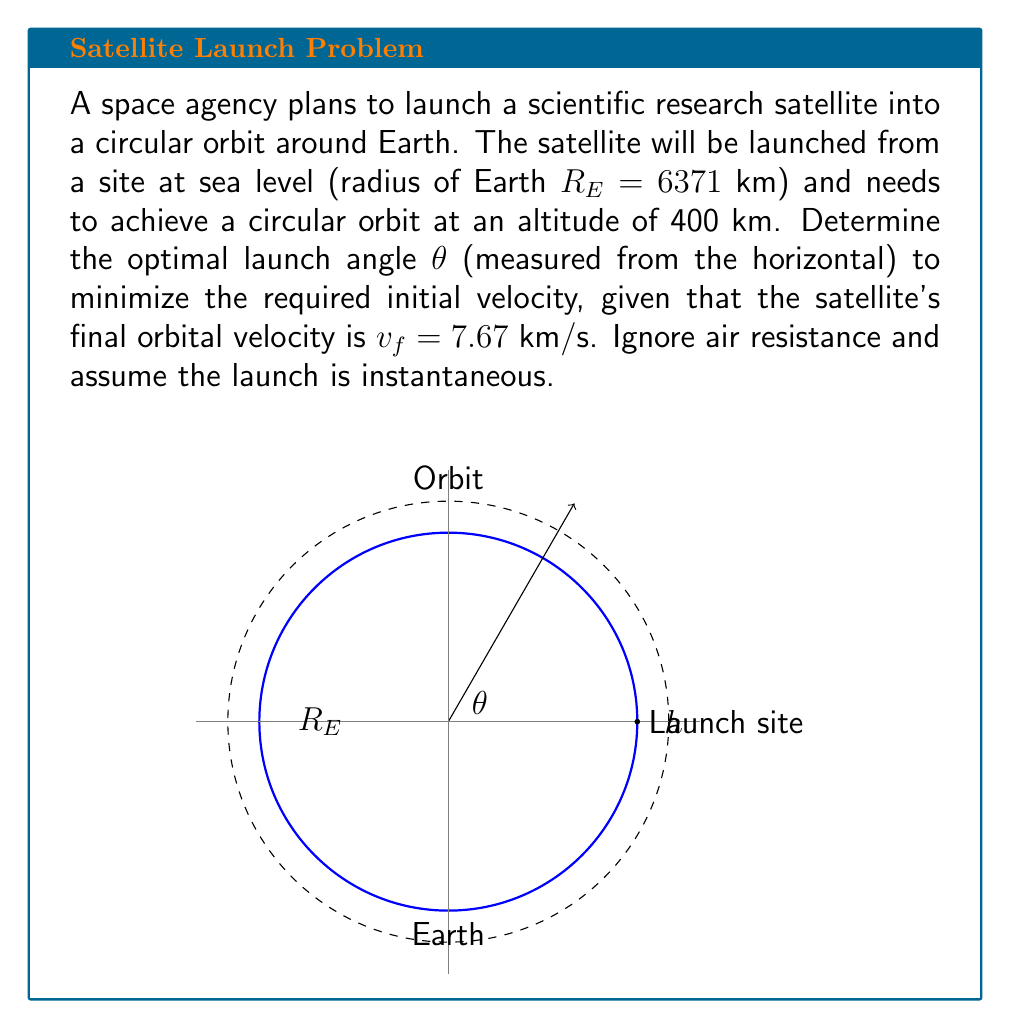Solve this math problem. Let's approach this step-by-step:

1) First, we need to understand that the optimal launch angle will be the one that requires the least change in velocity from the initial launch to the final orbital velocity.

2) The energy conservation equation for this scenario is:

   $$\frac{1}{2}v_i^2 - \frac{GM_E}{R_E} = \frac{1}{2}v_f^2 - \frac{GM_E}{R_E + h}$$

   where $v_i$ is the initial launch velocity, $G$ is the gravitational constant, $M_E$ is the mass of Earth, and $h$ is the orbital altitude.

3) We can simplify this by using the relation $GM_E = v_f^2(R_E + h)$ for circular orbits:

   $$\frac{1}{2}v_i^2 - \frac{v_f^2(R_E + h)}{R_E} = \frac{1}{2}v_f^2 - \frac{v_f^2(R_E + h)}{R_E + h}$$

4) Simplifying further:

   $$v_i^2 = v_f^2\left(2 - \frac{R_E}{R_E + h}\right)$$

5) Now, the initial velocity vector can be decomposed into horizontal and vertical components:

   $$v_{ix} = v_i \cos\theta$$
   $$v_{iy} = v_i \sin\theta$$

6) The final velocity is entirely horizontal in a circular orbit. To minimize $v_i$, we want $v_{ix}$ to be equal to $v_f$:

   $$v_f = v_i \cos\theta$$

7) Squaring both sides and substituting the expression for $v_i^2$ from step 4:

   $$v_f^2 = v_f^2\left(2 - \frac{R_E}{R_E + h}\right)\cos^2\theta$$

8) Solving for $\cos^2\theta$:

   $$\cos^2\theta = \frac{1}{2 - \frac{R_E}{R_E + h}}$$

9) Taking the arccosine and converting to degrees:

   $$\theta = \arccos\left(\sqrt{\frac{1}{2 - \frac{R_E}{R_E + h}}}\right) \cdot \frac{180}{\pi}$$

10) Plugging in the values ($R_E = 6371$ km, $h = 400$ km):

    $$\theta = \arccos\left(\sqrt{\frac{1}{2 - \frac{6371}{6371 + 400}}}\right) \cdot \frac{180}{\pi} \approx 85.9°$$
Answer: $85.9°$ 